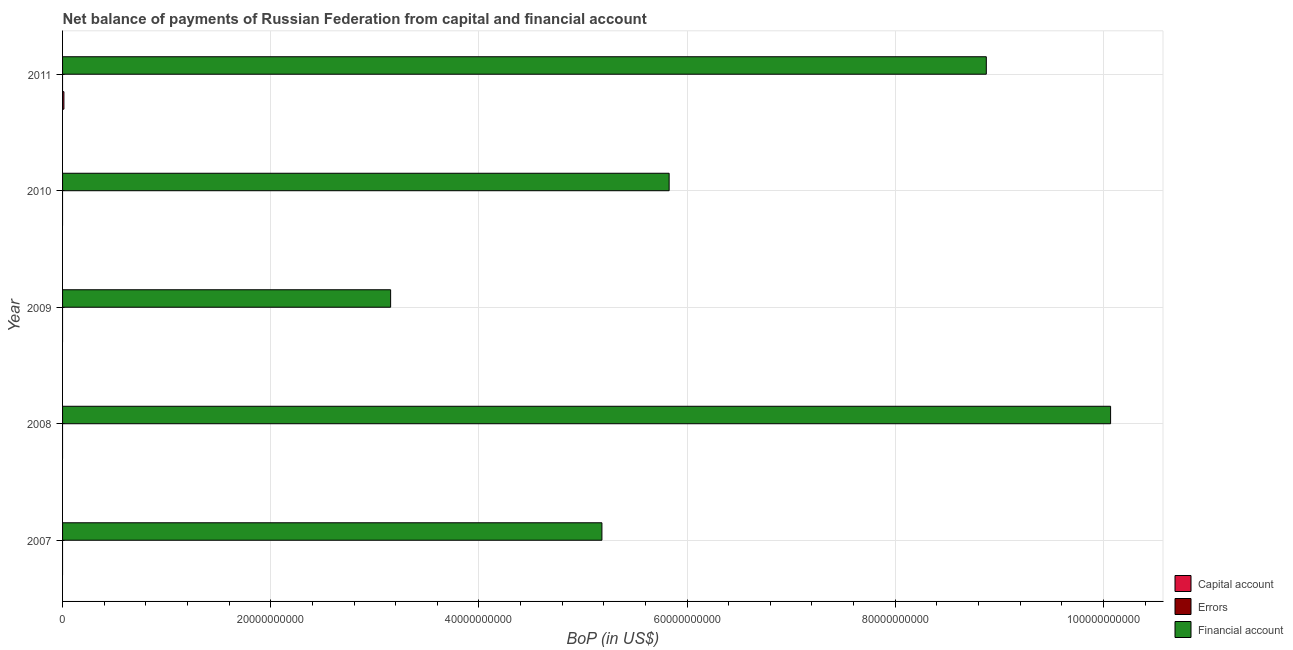Are the number of bars per tick equal to the number of legend labels?
Ensure brevity in your answer.  No. In how many cases, is the number of bars for a given year not equal to the number of legend labels?
Your answer should be very brief. 5. What is the amount of financial account in 2011?
Give a very brief answer. 8.88e+1. Across all years, what is the maximum amount of net capital account?
Give a very brief answer. 1.30e+08. Across all years, what is the minimum amount of financial account?
Your answer should be compact. 3.15e+1. What is the total amount of net capital account in the graph?
Offer a very short reply. 1.30e+08. What is the difference between the amount of financial account in 2009 and that in 2010?
Give a very brief answer. -2.68e+1. What is the difference between the amount of errors in 2007 and the amount of financial account in 2008?
Your answer should be very brief. -1.01e+11. What is the average amount of financial account per year?
Your answer should be compact. 6.62e+1. In how many years, is the amount of financial account greater than 40000000000 US$?
Your answer should be very brief. 4. What is the ratio of the amount of financial account in 2008 to that in 2009?
Provide a succinct answer. 3.19. Is the amount of financial account in 2008 less than that in 2010?
Provide a succinct answer. No. What is the difference between the highest and the second highest amount of financial account?
Ensure brevity in your answer.  1.19e+1. What is the difference between the highest and the lowest amount of financial account?
Provide a short and direct response. 6.92e+1. Are all the bars in the graph horizontal?
Make the answer very short. Yes. How many years are there in the graph?
Keep it short and to the point. 5. Does the graph contain any zero values?
Offer a very short reply. Yes. Does the graph contain grids?
Offer a terse response. Yes. How many legend labels are there?
Provide a succinct answer. 3. What is the title of the graph?
Your answer should be very brief. Net balance of payments of Russian Federation from capital and financial account. What is the label or title of the X-axis?
Provide a succinct answer. BoP (in US$). What is the label or title of the Y-axis?
Offer a terse response. Year. What is the BoP (in US$) in Financial account in 2007?
Offer a terse response. 5.18e+1. What is the BoP (in US$) in Errors in 2008?
Your answer should be compact. 0. What is the BoP (in US$) of Financial account in 2008?
Make the answer very short. 1.01e+11. What is the BoP (in US$) in Errors in 2009?
Provide a short and direct response. 0. What is the BoP (in US$) of Financial account in 2009?
Offer a terse response. 3.15e+1. What is the BoP (in US$) of Errors in 2010?
Make the answer very short. 0. What is the BoP (in US$) of Financial account in 2010?
Offer a very short reply. 5.83e+1. What is the BoP (in US$) in Capital account in 2011?
Offer a very short reply. 1.30e+08. What is the BoP (in US$) in Errors in 2011?
Offer a terse response. 0. What is the BoP (in US$) in Financial account in 2011?
Provide a short and direct response. 8.88e+1. Across all years, what is the maximum BoP (in US$) of Capital account?
Ensure brevity in your answer.  1.30e+08. Across all years, what is the maximum BoP (in US$) of Financial account?
Ensure brevity in your answer.  1.01e+11. Across all years, what is the minimum BoP (in US$) of Financial account?
Ensure brevity in your answer.  3.15e+1. What is the total BoP (in US$) of Capital account in the graph?
Offer a terse response. 1.30e+08. What is the total BoP (in US$) of Financial account in the graph?
Provide a succinct answer. 3.31e+11. What is the difference between the BoP (in US$) of Financial account in 2007 and that in 2008?
Your answer should be compact. -4.89e+1. What is the difference between the BoP (in US$) in Financial account in 2007 and that in 2009?
Ensure brevity in your answer.  2.03e+1. What is the difference between the BoP (in US$) in Financial account in 2007 and that in 2010?
Give a very brief answer. -6.46e+09. What is the difference between the BoP (in US$) in Financial account in 2007 and that in 2011?
Give a very brief answer. -3.69e+1. What is the difference between the BoP (in US$) of Financial account in 2008 and that in 2009?
Your answer should be compact. 6.92e+1. What is the difference between the BoP (in US$) of Financial account in 2008 and that in 2010?
Make the answer very short. 4.24e+1. What is the difference between the BoP (in US$) of Financial account in 2008 and that in 2011?
Your answer should be very brief. 1.19e+1. What is the difference between the BoP (in US$) in Financial account in 2009 and that in 2010?
Your answer should be compact. -2.68e+1. What is the difference between the BoP (in US$) in Financial account in 2009 and that in 2011?
Your answer should be compact. -5.72e+1. What is the difference between the BoP (in US$) of Financial account in 2010 and that in 2011?
Offer a terse response. -3.05e+1. What is the average BoP (in US$) in Capital account per year?
Make the answer very short. 2.59e+07. What is the average BoP (in US$) in Errors per year?
Offer a terse response. 0. What is the average BoP (in US$) of Financial account per year?
Make the answer very short. 6.62e+1. In the year 2011, what is the difference between the BoP (in US$) in Capital account and BoP (in US$) in Financial account?
Your answer should be compact. -8.86e+1. What is the ratio of the BoP (in US$) in Financial account in 2007 to that in 2008?
Your answer should be compact. 0.51. What is the ratio of the BoP (in US$) of Financial account in 2007 to that in 2009?
Your answer should be very brief. 1.64. What is the ratio of the BoP (in US$) in Financial account in 2007 to that in 2010?
Keep it short and to the point. 0.89. What is the ratio of the BoP (in US$) in Financial account in 2007 to that in 2011?
Ensure brevity in your answer.  0.58. What is the ratio of the BoP (in US$) of Financial account in 2008 to that in 2009?
Ensure brevity in your answer.  3.19. What is the ratio of the BoP (in US$) of Financial account in 2008 to that in 2010?
Keep it short and to the point. 1.73. What is the ratio of the BoP (in US$) of Financial account in 2008 to that in 2011?
Provide a short and direct response. 1.13. What is the ratio of the BoP (in US$) in Financial account in 2009 to that in 2010?
Keep it short and to the point. 0.54. What is the ratio of the BoP (in US$) of Financial account in 2009 to that in 2011?
Offer a terse response. 0.36. What is the ratio of the BoP (in US$) in Financial account in 2010 to that in 2011?
Make the answer very short. 0.66. What is the difference between the highest and the second highest BoP (in US$) in Financial account?
Your answer should be very brief. 1.19e+1. What is the difference between the highest and the lowest BoP (in US$) in Capital account?
Your answer should be very brief. 1.30e+08. What is the difference between the highest and the lowest BoP (in US$) of Financial account?
Your answer should be compact. 6.92e+1. 